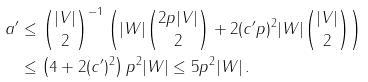Convert formula to latex. <formula><loc_0><loc_0><loc_500><loc_500>a ^ { \prime } & \leq \binom { | V | } { 2 } ^ { - 1 } \left ( | W | \binom { 2 p | V | } { 2 } + 2 ( c ^ { \prime } p ) ^ { 2 } | W | \binom { | V | } { 2 } \right ) \\ & \leq \left ( 4 + 2 ( c ^ { \prime } ) ^ { 2 } \right ) p ^ { 2 } | W | \leq 5 p ^ { 2 } | W | \, .</formula> 